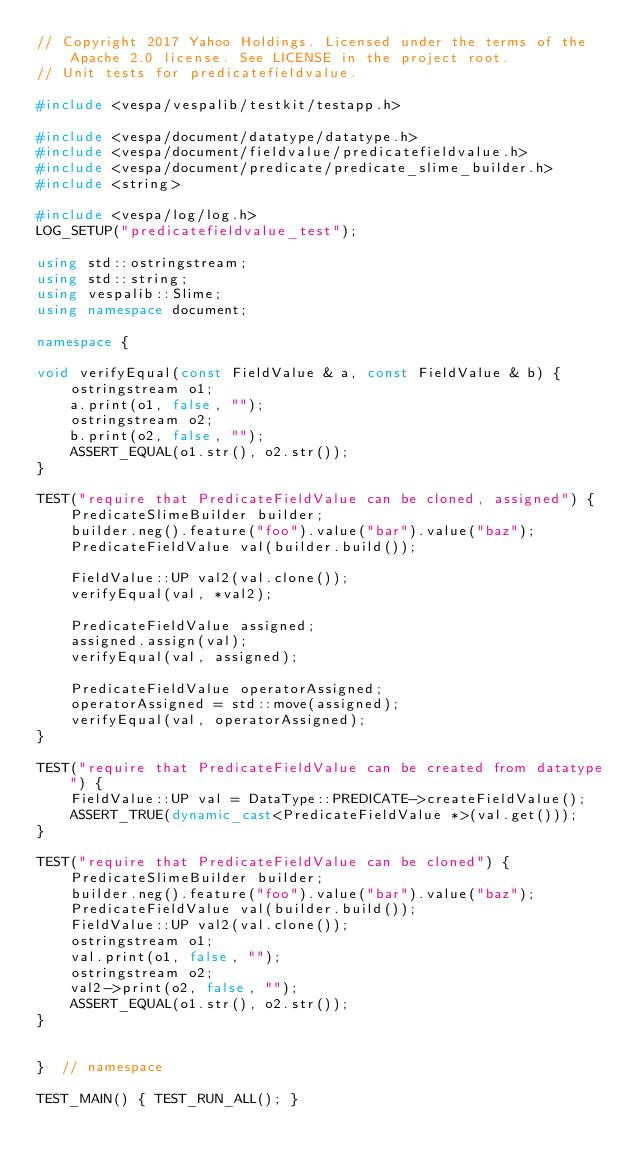Convert code to text. <code><loc_0><loc_0><loc_500><loc_500><_C++_>// Copyright 2017 Yahoo Holdings. Licensed under the terms of the Apache 2.0 license. See LICENSE in the project root.
// Unit tests for predicatefieldvalue.

#include <vespa/vespalib/testkit/testapp.h>

#include <vespa/document/datatype/datatype.h>
#include <vespa/document/fieldvalue/predicatefieldvalue.h>
#include <vespa/document/predicate/predicate_slime_builder.h>
#include <string>

#include <vespa/log/log.h>
LOG_SETUP("predicatefieldvalue_test");

using std::ostringstream;
using std::string;
using vespalib::Slime;
using namespace document;

namespace {

void verifyEqual(const FieldValue & a, const FieldValue & b) {
    ostringstream o1;
    a.print(o1, false, "");
    ostringstream o2;
    b.print(o2, false, "");
    ASSERT_EQUAL(o1.str(), o2.str());
}

TEST("require that PredicateFieldValue can be cloned, assigned") {
    PredicateSlimeBuilder builder;
    builder.neg().feature("foo").value("bar").value("baz");
    PredicateFieldValue val(builder.build());

    FieldValue::UP val2(val.clone());
    verifyEqual(val, *val2);

    PredicateFieldValue assigned;
    assigned.assign(val);
    verifyEqual(val, assigned);

    PredicateFieldValue operatorAssigned;
    operatorAssigned = std::move(assigned);
    verifyEqual(val, operatorAssigned);
}

TEST("require that PredicateFieldValue can be created from datatype") {
    FieldValue::UP val = DataType::PREDICATE->createFieldValue();
    ASSERT_TRUE(dynamic_cast<PredicateFieldValue *>(val.get()));
}

TEST("require that PredicateFieldValue can be cloned") {
    PredicateSlimeBuilder builder;
    builder.neg().feature("foo").value("bar").value("baz");
    PredicateFieldValue val(builder.build());
    FieldValue::UP val2(val.clone());
    ostringstream o1;
    val.print(o1, false, "");
    ostringstream o2;
    val2->print(o2, false, "");
    ASSERT_EQUAL(o1.str(), o2.str());
}


}  // namespace

TEST_MAIN() { TEST_RUN_ALL(); }
</code> 